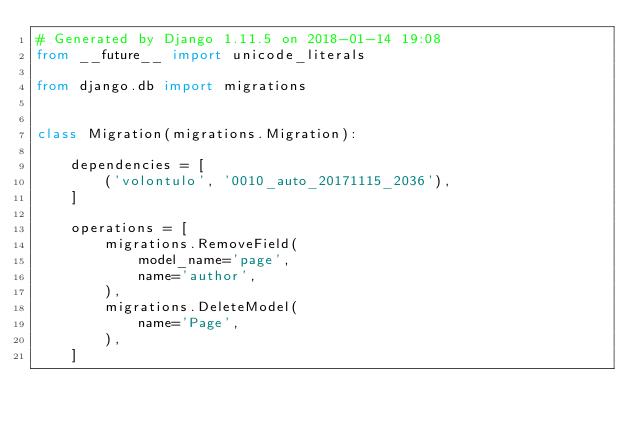Convert code to text. <code><loc_0><loc_0><loc_500><loc_500><_Python_># Generated by Django 1.11.5 on 2018-01-14 19:08
from __future__ import unicode_literals

from django.db import migrations


class Migration(migrations.Migration):

    dependencies = [
        ('volontulo', '0010_auto_20171115_2036'),
    ]

    operations = [
        migrations.RemoveField(
            model_name='page',
            name='author',
        ),
        migrations.DeleteModel(
            name='Page',
        ),
    ]
</code> 